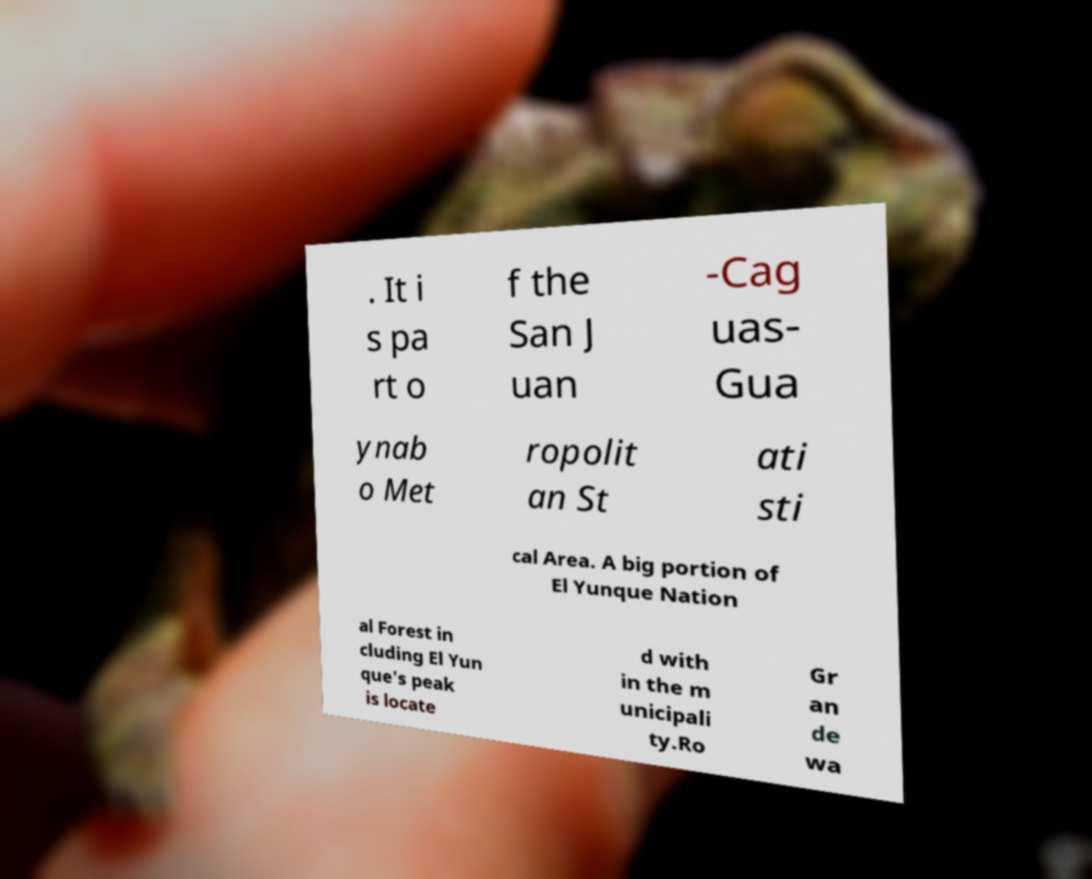Can you read and provide the text displayed in the image?This photo seems to have some interesting text. Can you extract and type it out for me? . It i s pa rt o f the San J uan -Cag uas- Gua ynab o Met ropolit an St ati sti cal Area. A big portion of El Yunque Nation al Forest in cluding El Yun que's peak is locate d with in the m unicipali ty.Ro Gr an de wa 